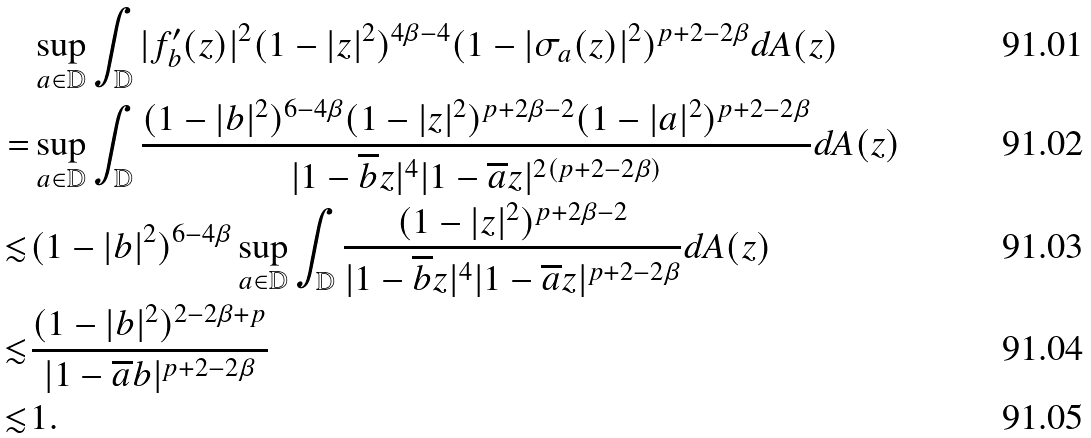Convert formula to latex. <formula><loc_0><loc_0><loc_500><loc_500>& \sup _ { a \in \mathbb { D } } \int _ { \mathbb { D } } | f _ { b } ^ { \prime } ( z ) | ^ { 2 } ( 1 - | z | ^ { 2 } ) ^ { 4 \beta - 4 } ( 1 - | \sigma _ { a } ( z ) | ^ { 2 } ) ^ { p + 2 - 2 \beta } d A ( z ) \\ = & \sup _ { a \in \mathbb { D } } \int _ { \mathbb { D } } \frac { ( 1 - | b | ^ { 2 } ) ^ { 6 - 4 \beta } ( 1 - | z | ^ { 2 } ) ^ { p + 2 \beta - 2 } ( 1 - | a | ^ { 2 } ) ^ { p + 2 - 2 \beta } } { | 1 - \overline { b } z | ^ { 4 } | 1 - \overline { a } z | ^ { 2 ( p + 2 - 2 \beta ) } } d A ( z ) \\ \lesssim & ( 1 - | b | ^ { 2 } ) ^ { 6 - 4 \beta } \sup _ { a \in \mathbb { D } } \int _ { \mathbb { D } } \frac { ( 1 - | z | ^ { 2 } ) ^ { p + 2 \beta - 2 } } { | 1 - \overline { b } z | ^ { 4 } | 1 - \overline { a } z | ^ { p + 2 - 2 \beta } } d A ( z ) \\ \lesssim & \frac { ( 1 - | b | ^ { 2 } ) ^ { 2 - 2 \beta + p } } { | 1 - \overline { a } b | ^ { p + 2 - 2 \beta } } \\ \lesssim & 1 .</formula> 